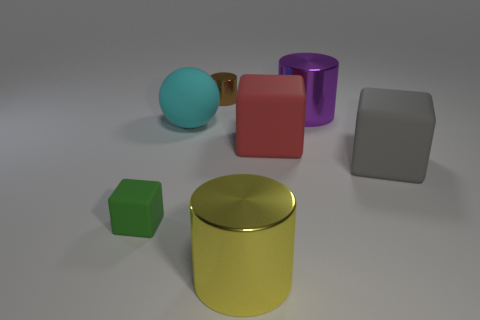Does the big gray thing have the same shape as the matte thing in front of the big gray cube?
Offer a very short reply. Yes. How many rubber cubes are on the left side of the big purple thing and to the right of the large ball?
Your response must be concise. 1. How many gray things are either small matte blocks or small cylinders?
Give a very brief answer. 0. There is a large metal object behind the yellow metal object; is it the same color as the large shiny cylinder that is in front of the green rubber thing?
Provide a succinct answer. No. What color is the big matte thing that is on the left side of the big metallic thing in front of the large matte cube that is in front of the red thing?
Your answer should be compact. Cyan. Is there a big yellow object behind the tiny thing that is behind the big purple object?
Offer a terse response. No. Does the small thing behind the green rubber object have the same shape as the green rubber thing?
Offer a terse response. No. Are there any other things that are the same shape as the large gray object?
Provide a short and direct response. Yes. What number of cubes are either big rubber things or large red objects?
Your answer should be compact. 2. What number of yellow matte cylinders are there?
Keep it short and to the point. 0. 